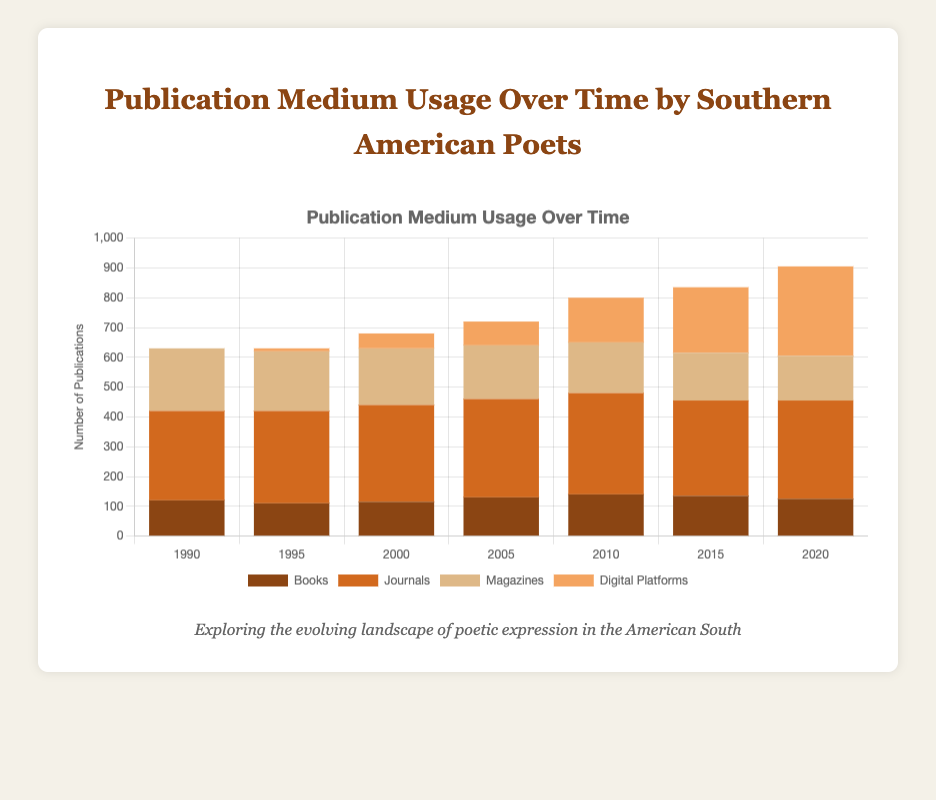What is the total number of publications in 1990? Eyeball the figure to sum up the heights of the bars for each medium in 1990. The publications are Books (120), Journals (300), Magazines (210), and Digital Platforms (0). Adding them gives 120 + 300 + 210 + 0 = 630
Answer: 630 Has the usage of digital platforms increased or decreased over time? Visually inspect the height of the "Digital Platforms" bar for each year. It starts at 0 in 1990, then rises to 300 in 2020.
Answer: Increased Which publication medium had the highest number of publications in 2010? Compare the heights of the bars for 2010. The highest bar corresponds to Journals with a value of 340.
Answer: Journals How many total publications were recorded across all mediums in 2005 and 2010, and which year had more publications? Sum the heights of the bars for both years: For 2005, we have 130 (Books) + 330 (Journals) + 180 (Magazines) + 80 (Digital Platforms) = 720. For 2010, it's 140 (Books) + 340 (Journals) + 170 (Magazines) + 150 (Digital Platforms) = 800. The 2010 total is greater than 2005.
Answer: 2010 had more publications (800) How does the publication behavior in 1995 compare to 2020 in terms of digital platforms? Look at the heights of the "Digital Platforms" bars in 1995 and 2020. In 1995, the value is 10, while in 2020 it is 300.
Answer: Digital platform usage increased significantly During which year did magazines see their highest usage? Compare the heights of the "Magazines" bars for each year. The highest bar is in 1990 with a value of 210.
Answer: 1990 Calculate the average number of journal publications between 1990 and 2020. The journal publication numbers are [300, 310, 325, 330, 340, 320, 330]. Sum these values (300 + 310 + 325 + 330 + 340 + 320 + 330 = 2255) and then divide by the number of data points (7), giving 2255 / 7 ≈ 322.14.
Answer: 322.14 Which year showed the smallest number of total publications across all mediums? Compare the total heights of the bars for each year. After checking, 1990 has the lowest total number of publications = 630.
Answer: 1990 In which year did books see their maximum publications? Compare the heights of the "Books" bars for each year. The highest bar is in 2010 with a value of 140.
Answer: 2010 